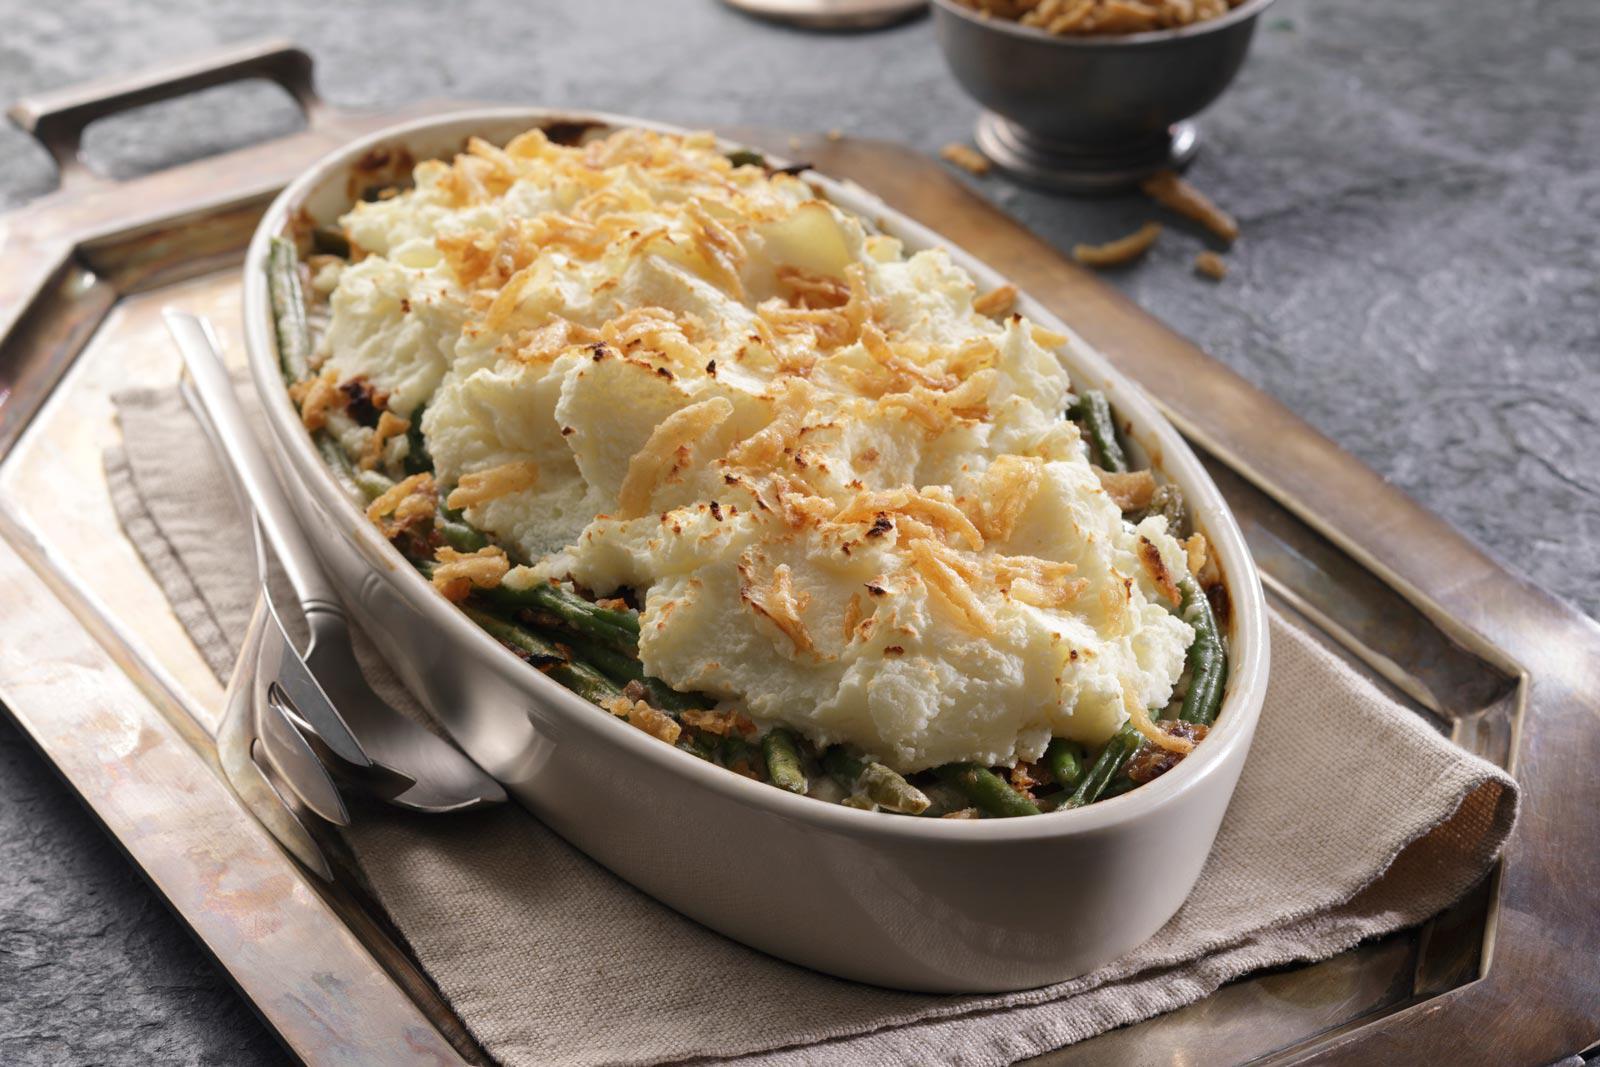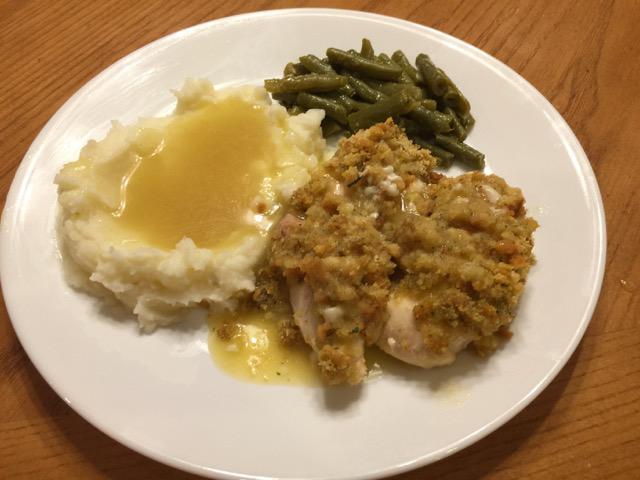The first image is the image on the left, the second image is the image on the right. Analyze the images presented: Is the assertion "There is a utensil sitting in the dish of food in the image on the right." valid? Answer yes or no. No. The first image is the image on the left, the second image is the image on the right. For the images shown, is this caption "there is a serving spoon in the disg of potatoes" true? Answer yes or no. No. 